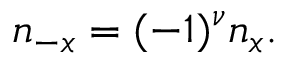<formula> <loc_0><loc_0><loc_500><loc_500>n _ { - x } = ( - 1 ) ^ { \nu } n _ { x } .</formula> 